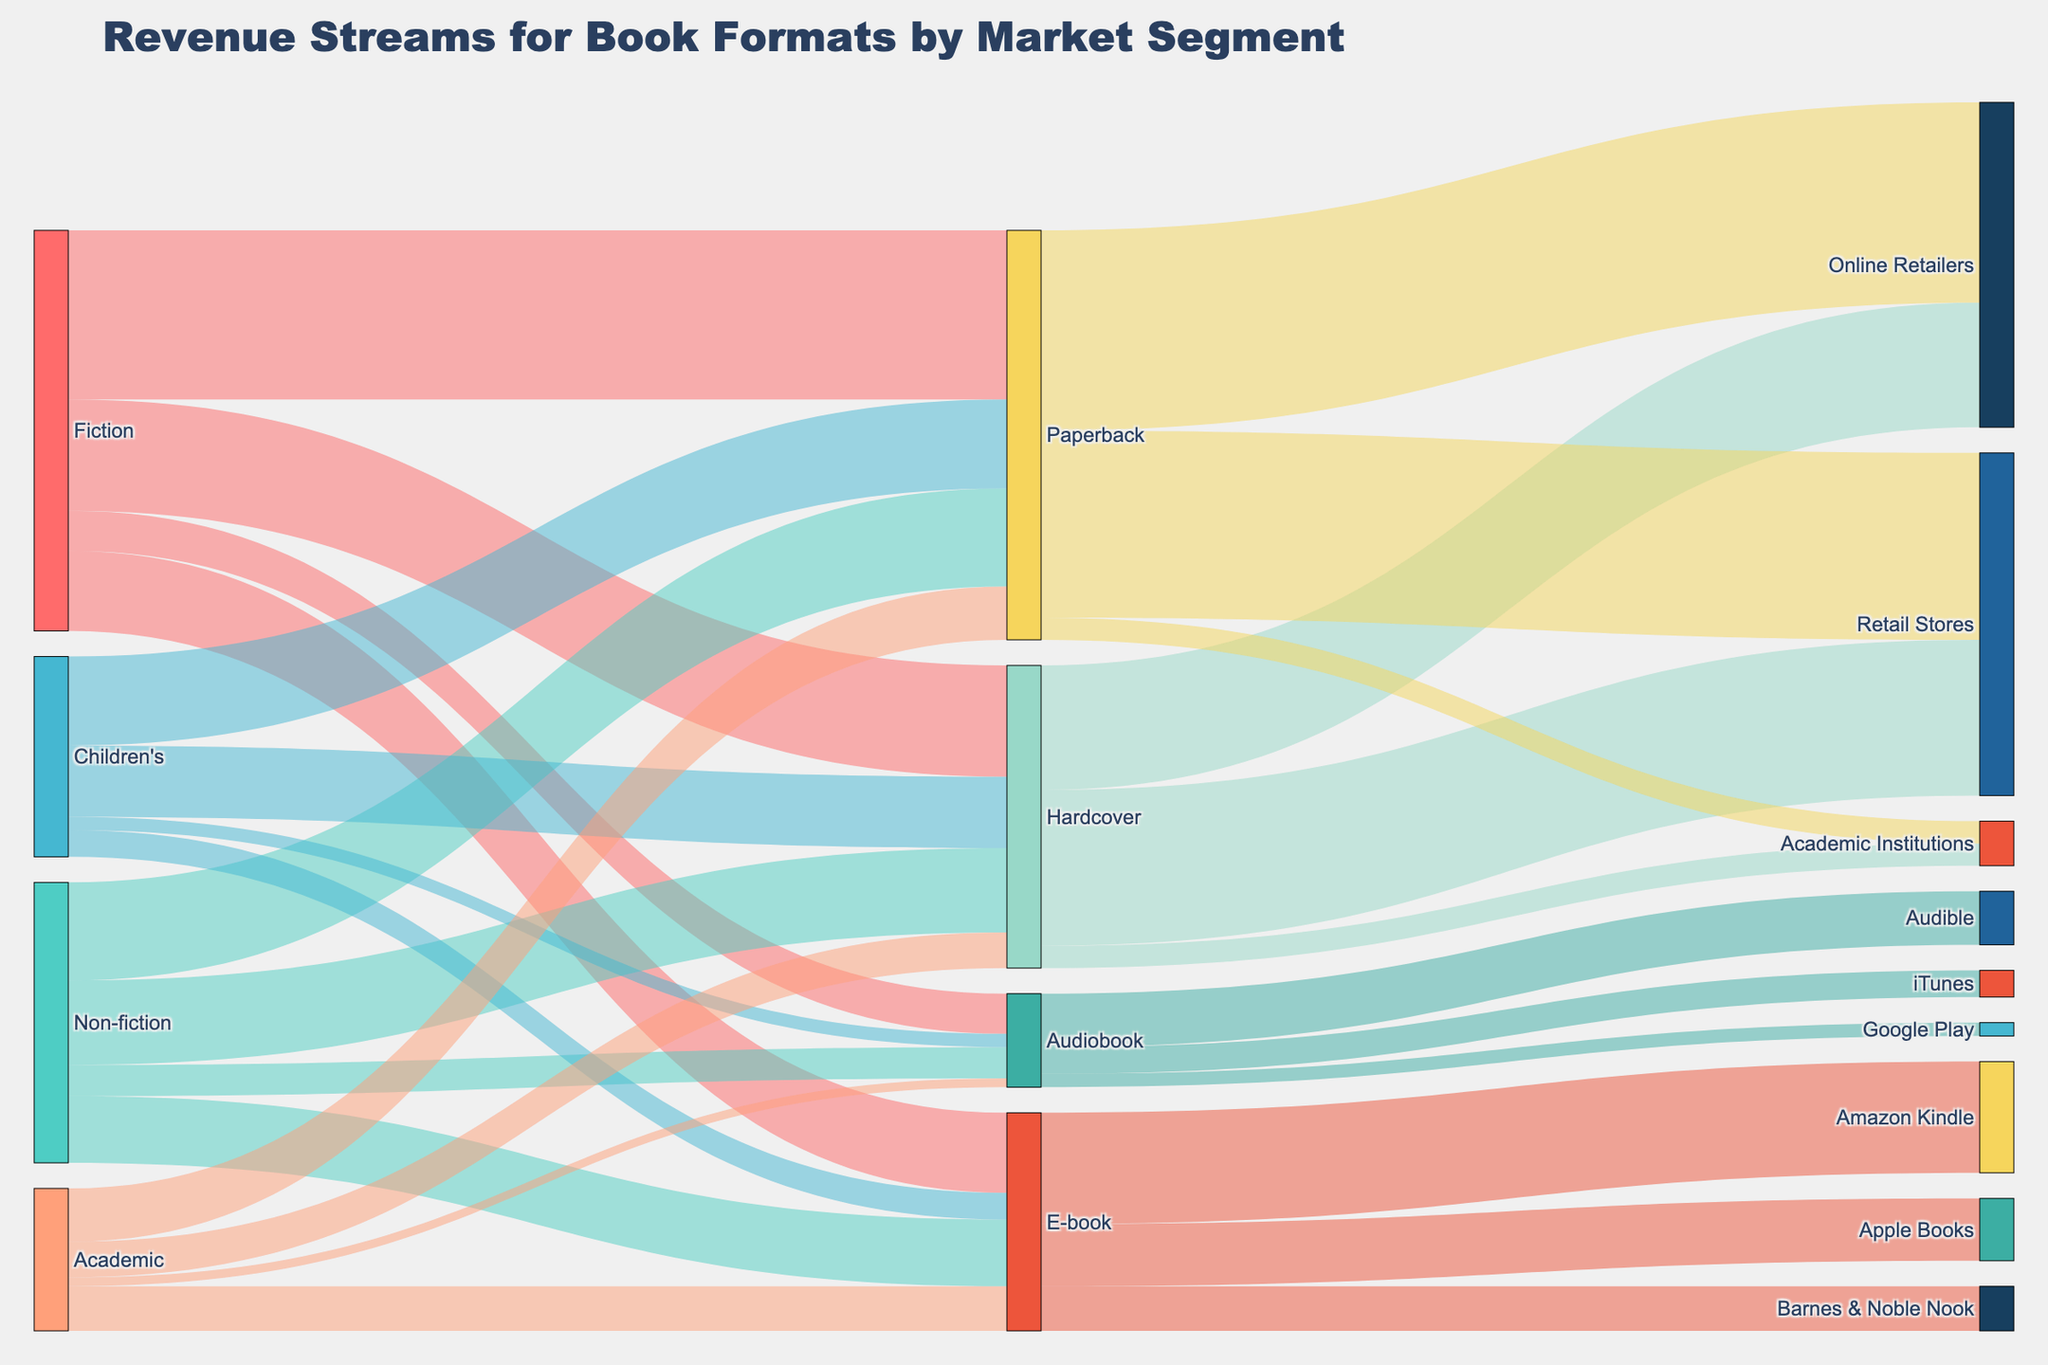What is the title of the figure? The title can be found at the top of the Sankey diagram. It is usually larger and more prominent compared to other text elements.
Answer: Revenue Streams for Book Formats by Market Segment Which market segment generates the most revenue from hardcover sales? Sum up all the values associated with the "Hardcover" target. Fiction contributes $2,500,000, Non-fiction $1,900,000, Children's $1,600,000, and Academic $800,000. Fiction has the highest value.
Answer: Fiction What is the total revenue generated from e-books across all market segments? Sum up all the values associated with the "E-book" target. Fiction contributes $1,800,000, Non-fiction $1,500,000, Children's $600,000, and Academic $1,000,000.
Answer: $4,900,000 Which format has the lowest revenue from the Non-fiction segment? Compare the values for hardcover, paperback, e-book, and audiobook within the Non-fiction segment. Hardcover: $1,900,000, Paperback: $2,200,000, E-book: $1,500,000, Audiobook: $700,000. Audiobook has the lowest value.
Answer: Audiobook How much more revenue does the Fiction market segment generate from paperbacks compared to audiobooks? Subtract the revenue from audiobooks in Fiction from the revenue from paperbacks in Fiction. Paperback: $3,800,000, Audiobook: $900,000. The difference is $3,800,000 - $900,000.
Answer: $2,900,000 Which online retailer generates the most revenue from e-books? Compare the values for Amazon Kindle, Apple Books, and Barnes & Noble Nook within the E-book target. Amazon Kindle: $2,500,000, Apple Books: $1,400,000, Barnes & Noble Nook: $1,000,000. Amazon Kindle has the highest value.
Answer: Amazon Kindle Is the revenue from Academic market segment higher for hardcover or paperback? Compare the values for hardcover and paperback in the Academic segment. Hardcover: $800,000, Paperback: $1,200,000. Paperback is higher.
Answer: Paperback How does the audiobook revenue from the Children's segment compare to that from Non-fiction segment? Compare the values for audiobooks within the Children's and Non-fiction segments. Children's: $300,000, Non-fiction: $700,000.
Answer: Non-fiction is higher What is the total revenue generated from all market segments combined? Sum up the values for each format across all segments. Hardcover: $2,500,000 + $1,900,000 + $1,600,000 + $800,000 = $6,800,000
Paperback: $3,800,000 + $2,200,000 + $2,000,000 + $1,200,000 = $9,200,000
E-book: $1,800,000 + $1,500,000 + $600,000 + $1,000,000 = $4,900,000
Audiobook: $900,000 + $700,000 + $300,000 + $200,000 = $2,100,000
Total = $22,000,000.
Answer: $22,000,000 